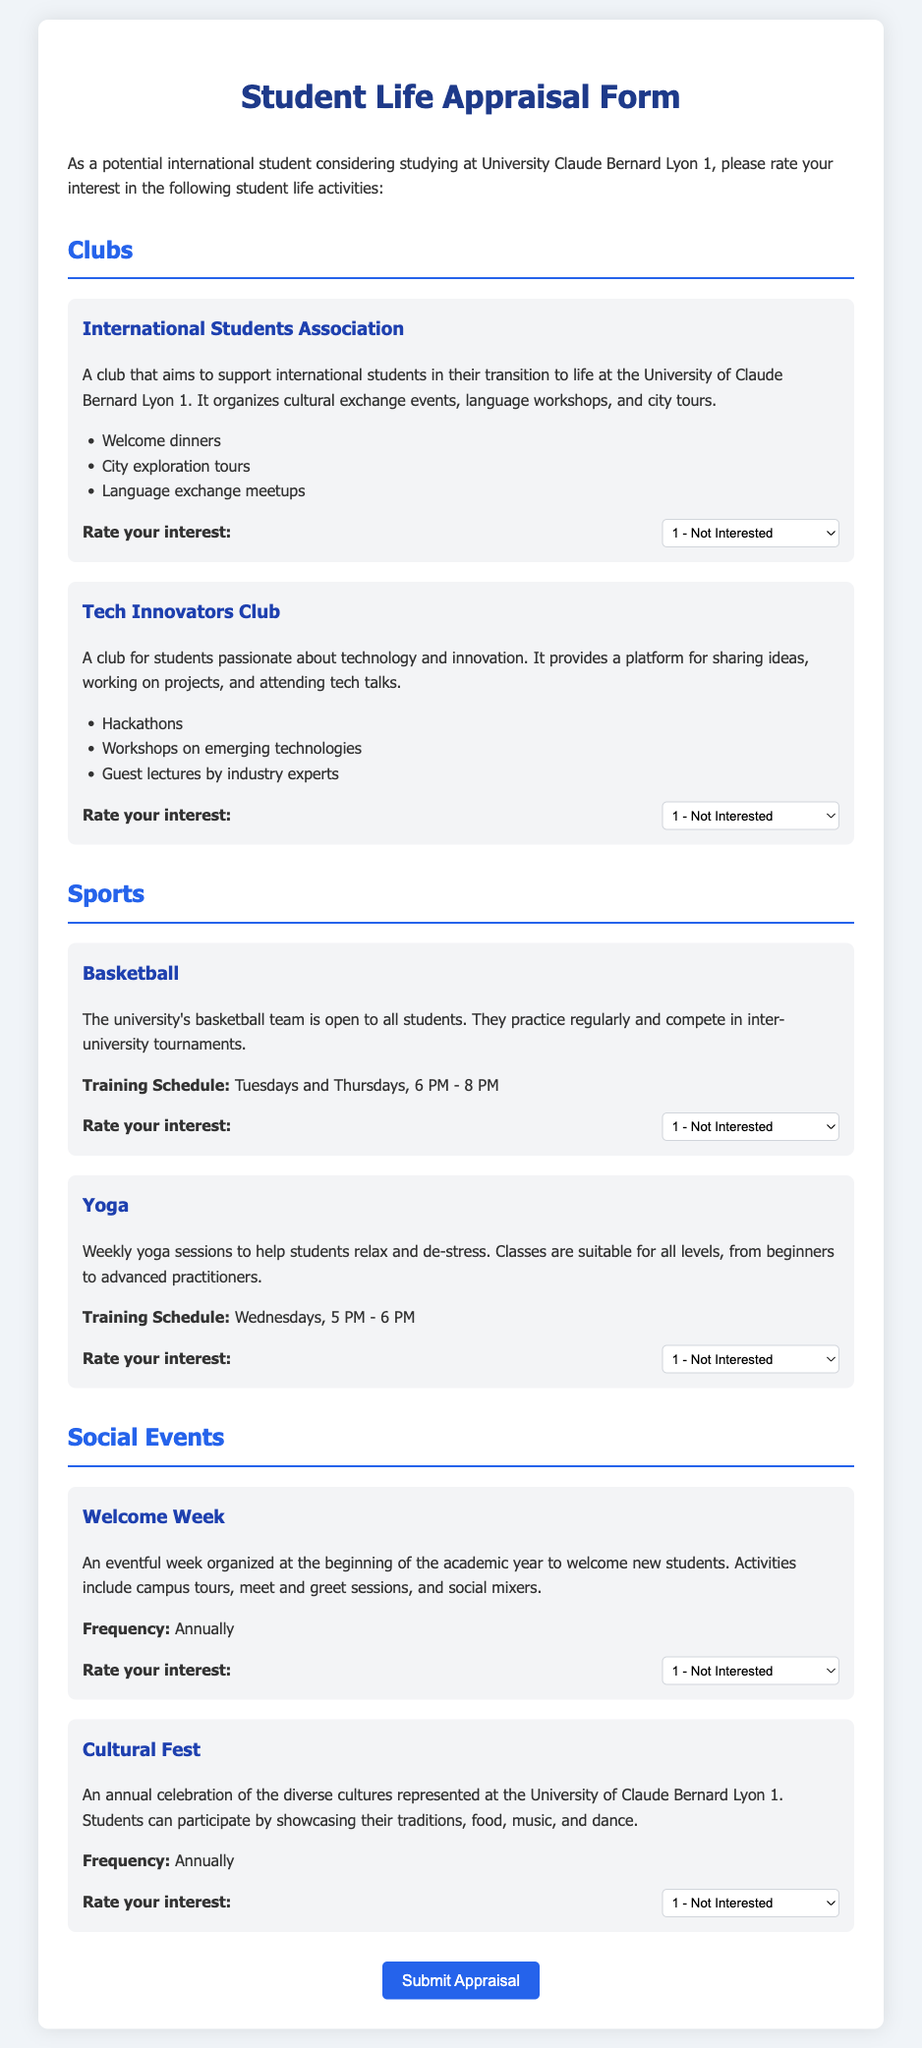What is the name of the club that supports international students? The document mentions the "International Students Association" as a club that aims to support international students.
Answer: International Students Association How many sessions does the Yoga class have per week? The Yoga class is mentioned to have sessions that occur weekly, specifically on Wednesdays.
Answer: 1 What types of events are organized by the International Students Association? The document lists welcome dinners, city exploration tours, and language exchange meetups as events organized by the club.
Answer: Welcome dinners, city exploration tours, language exchange meetups On which days does the Basketball team practice? The document specifies that the basketball team practices on Tuesdays and Thursdays.
Answer: Tuesdays and Thursdays How often does the Cultural Fest occur? The document indicates that the Cultural Fest is an annual event.
Answer: Annually How many clubs are mentioned in the Student Life Appraisal Form? The document refers to two clubs: the International Students Association and the Tech Innovators Club.
Answer: 2 What is the focus of the Tech Innovators Club? The document describes the club as a platform for students passionate about technology and innovation.
Answer: Technology and innovation During what event do students participate by showcasing their traditions? The Cultural Fest is noted in the document as the event where students showcase their traditions, food, music, and dance.
Answer: Cultural Fest 